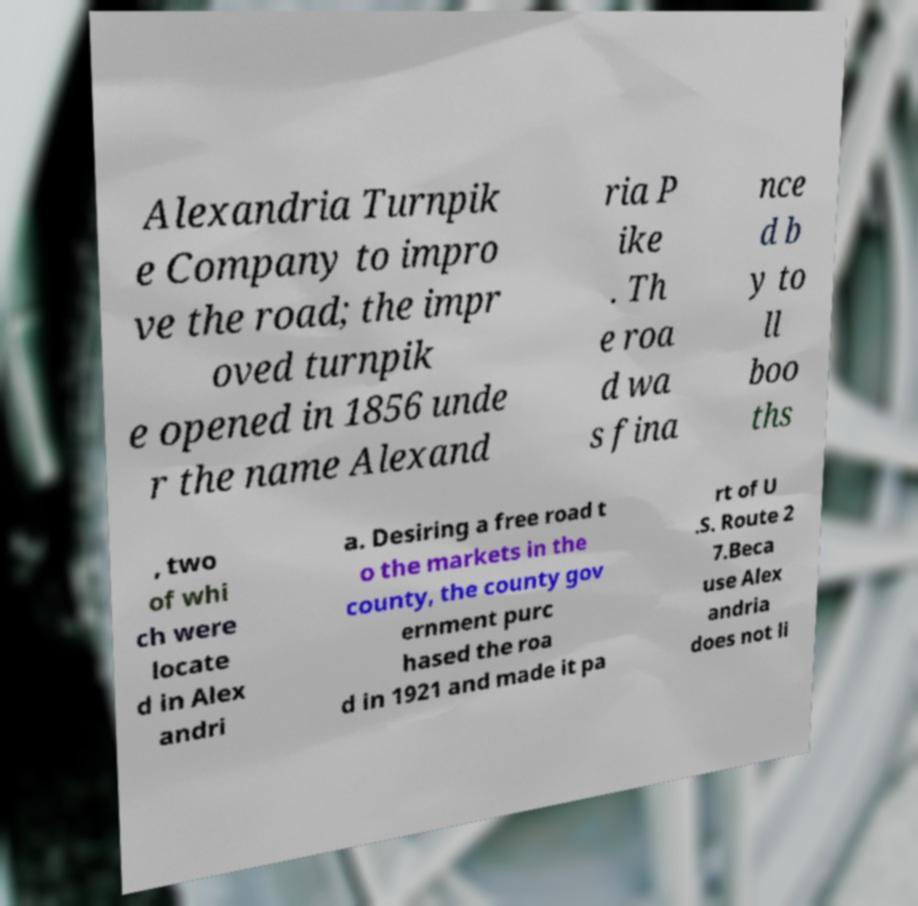Could you extract and type out the text from this image? Alexandria Turnpik e Company to impro ve the road; the impr oved turnpik e opened in 1856 unde r the name Alexand ria P ike . Th e roa d wa s fina nce d b y to ll boo ths , two of whi ch were locate d in Alex andri a. Desiring a free road t o the markets in the county, the county gov ernment purc hased the roa d in 1921 and made it pa rt of U .S. Route 2 7.Beca use Alex andria does not li 